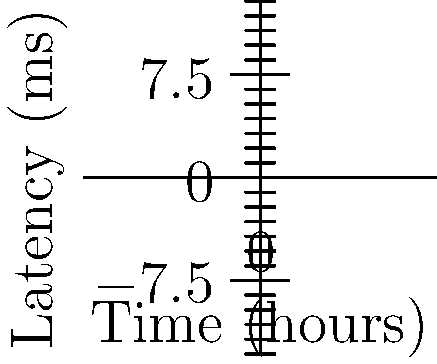As a music producer, you're assessing different streaming platforms for a new electronic music release. The graph shows network latency over time for three platforms. Which platform demonstrates the most consistent latency, making it ideal for streaming time-sensitive electronic music? To determine the most consistent latency, we need to analyze the rate of change for each platform:

1. Platform A (blue line):
   - Starts at 10ms and ends at 85ms
   - Total increase: 75ms over 5 hours
   - Rate of change: 15ms/hour

2. Platform B (red line):
   - Starts at 5ms and ends at 35ms
   - Total increase: 30ms over 5 hours
   - Rate of change: 6ms/hour

3. Platform C (green line):
   - Starts at 15ms and ends at 120ms
   - Total increase: 105ms over 5 hours
   - Rate of change: 21ms/hour

Platform B has the smallest rate of change (6ms/hour), indicating the most consistent latency over time. This consistency is crucial for streaming time-sensitive electronic music, as it minimizes potential timing issues and maintains a stable listening experience.

While Platform B starts with the lowest latency (5ms) and maintains the lowest latency throughout the observed period, the question specifically asks about consistency rather than lowest overall latency.
Answer: Platform B 